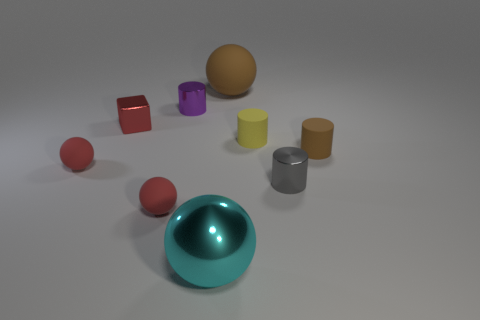Subtract all blue balls. Subtract all red blocks. How many balls are left? 4 Add 1 large cyan balls. How many objects exist? 10 Subtract all balls. How many objects are left? 5 Subtract 1 brown cylinders. How many objects are left? 8 Subtract all large metallic spheres. Subtract all metal cylinders. How many objects are left? 6 Add 7 tiny red objects. How many tiny red objects are left? 10 Add 1 metal objects. How many metal objects exist? 5 